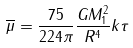Convert formula to latex. <formula><loc_0><loc_0><loc_500><loc_500>\overline { \mu } = \frac { 7 5 } { 2 2 4 \pi } \frac { G M ^ { 2 } _ { 1 } } { R ^ { 4 } } k \tau</formula> 